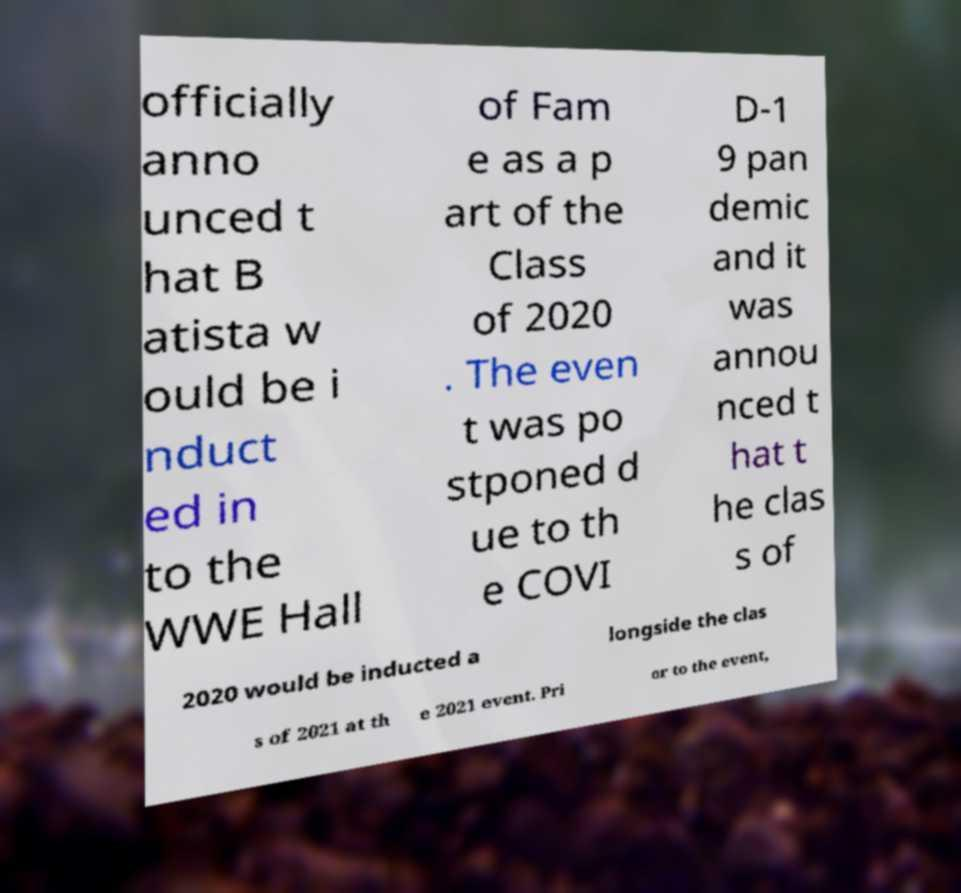Can you accurately transcribe the text from the provided image for me? officially anno unced t hat B atista w ould be i nduct ed in to the WWE Hall of Fam e as a p art of the Class of 2020 . The even t was po stponed d ue to th e COVI D-1 9 pan demic and it was annou nced t hat t he clas s of 2020 would be inducted a longside the clas s of 2021 at th e 2021 event. Pri or to the event, 